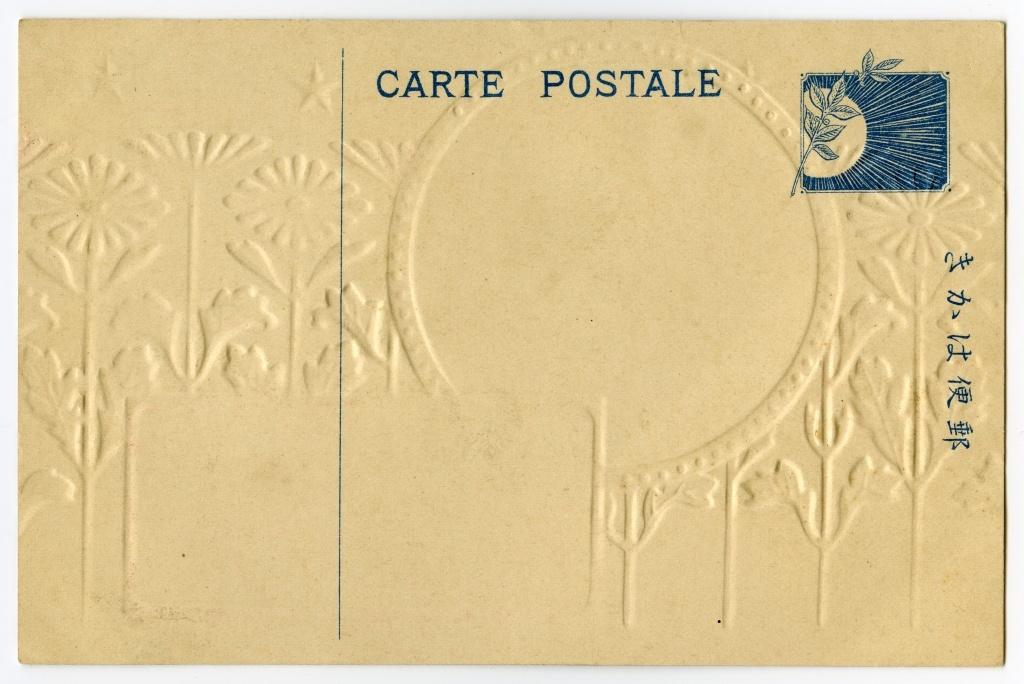What does the top say?
Provide a succinct answer. Carte postale. 